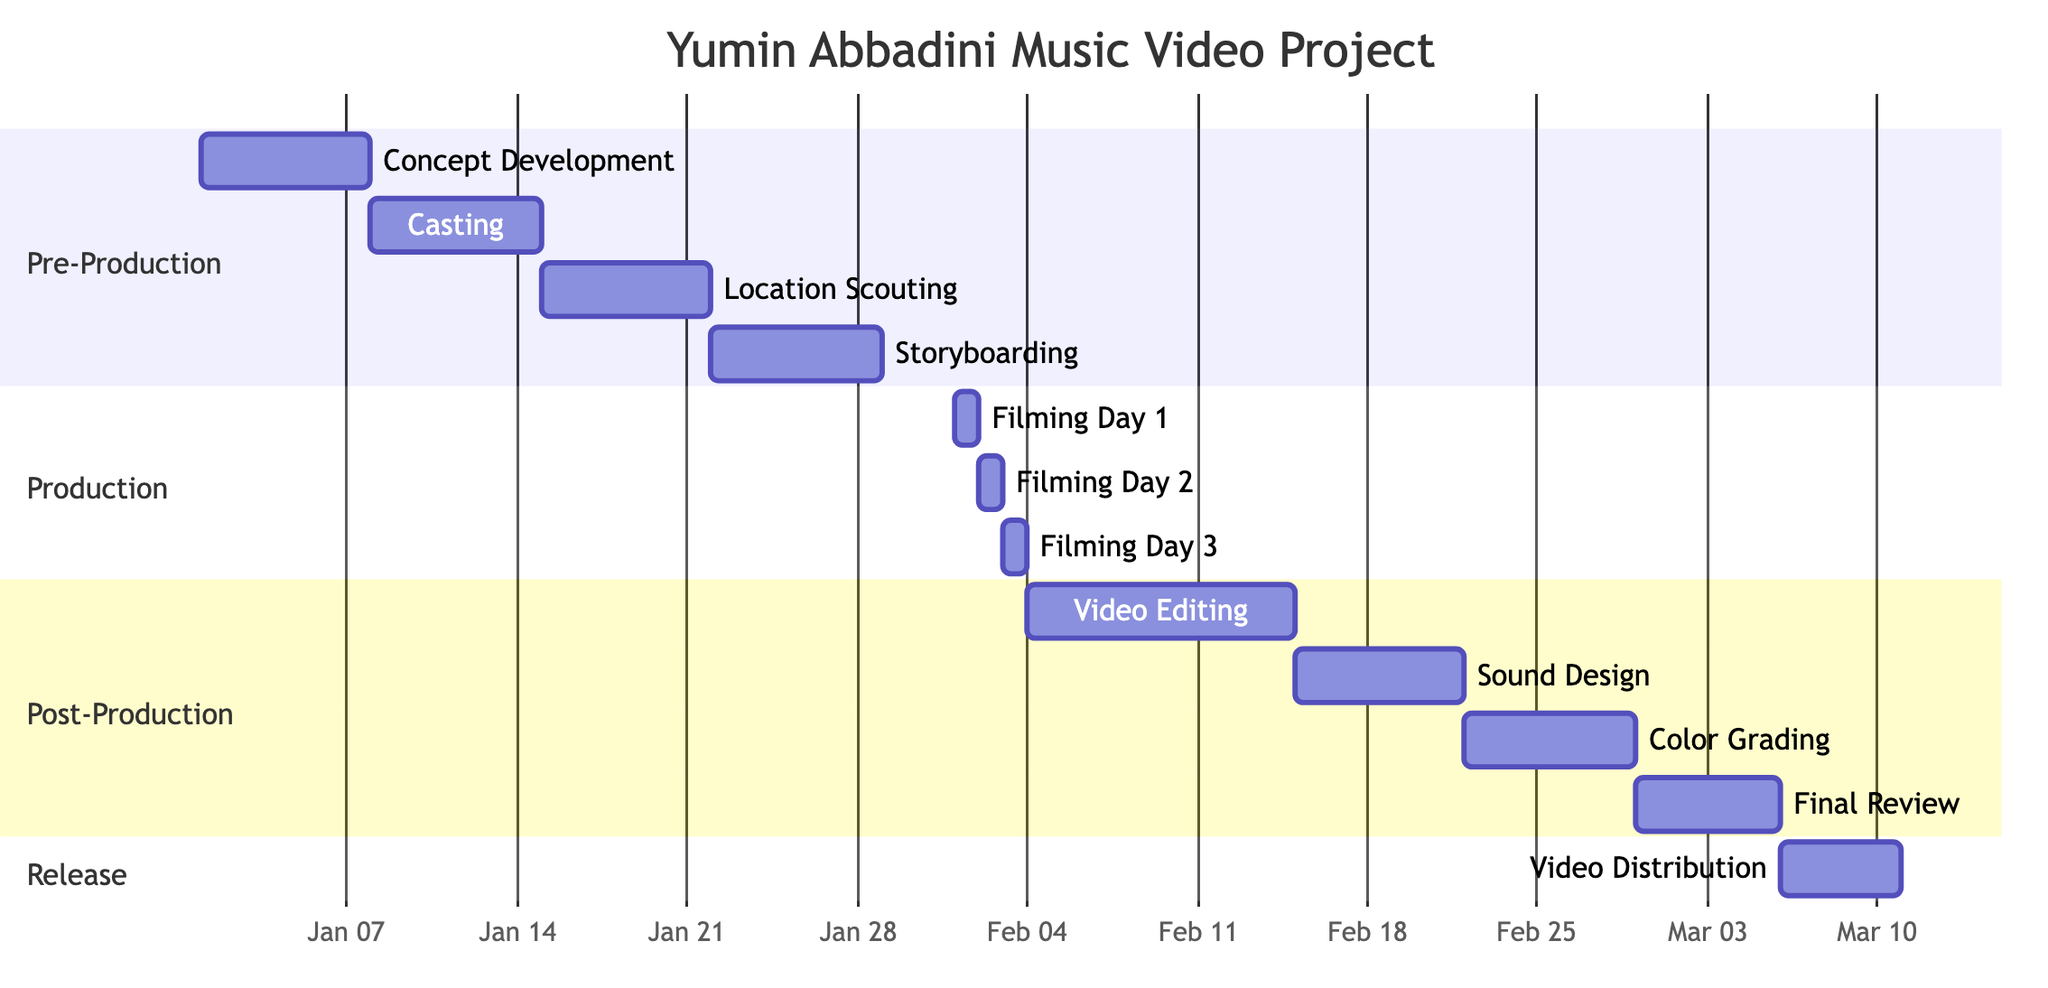What is the duration of the Pre-Production phase? The Pre-Production phase includes four tasks, which start on January 1, 2024, and end on January 28, 2024. This means that it lasts for 28 days.
Answer: 28 days Which task comes after Location Scouting? Looking at the order of tasks listed in the Pre-Production section, the task that follows Location Scouting, which ends on January 21, 2024, is Storyboarding, starting on January 22, 2024.
Answer: Storyboarding How many filming days are there in the Production phase? The Production section lists three specific tasks: Filming Day 1, Filming Day 2, and Filming Day 3. Therefore, the total number of filming days is 3.
Answer: 3 When does the Sound Design task start? The Sound Design task is listed within the Post-Production phase and starts on February 15, 2024, as indicated in the schedule.
Answer: February 15, 2024 What is the end date of the Project? The entire project concludes with the Video Distribution task, which starts on March 6, 2024, and ends on March 10, 2024. Thus, the end date of the project is March 10, 2024.
Answer: March 10, 2024 Which task overlaps with the Video Editing task? The Video Editing task runs from February 4 to February 14, 2024, and the Sound Design task starts on February 15, 2024. Therefore, the task that overlaps with Video Editing is none; it is distinct and does not overlap with any other task since Sound Design begins right after it.
Answer: None What is the gap between Color Grading and Final Review? The Color Grading task ends on February 28, 2024, while the Final Review starts on February 29, 2024. There is no gap since the latter begins the day after the former ends, suggesting an immediate transition.
Answer: 0 days What are the assigned days for Filming Day 2? Filming Day 2 is specified in the Production section and is assigned a single day, which is February 2, 2024, as indicated in the timeline.
Answer: February 2, 2024 